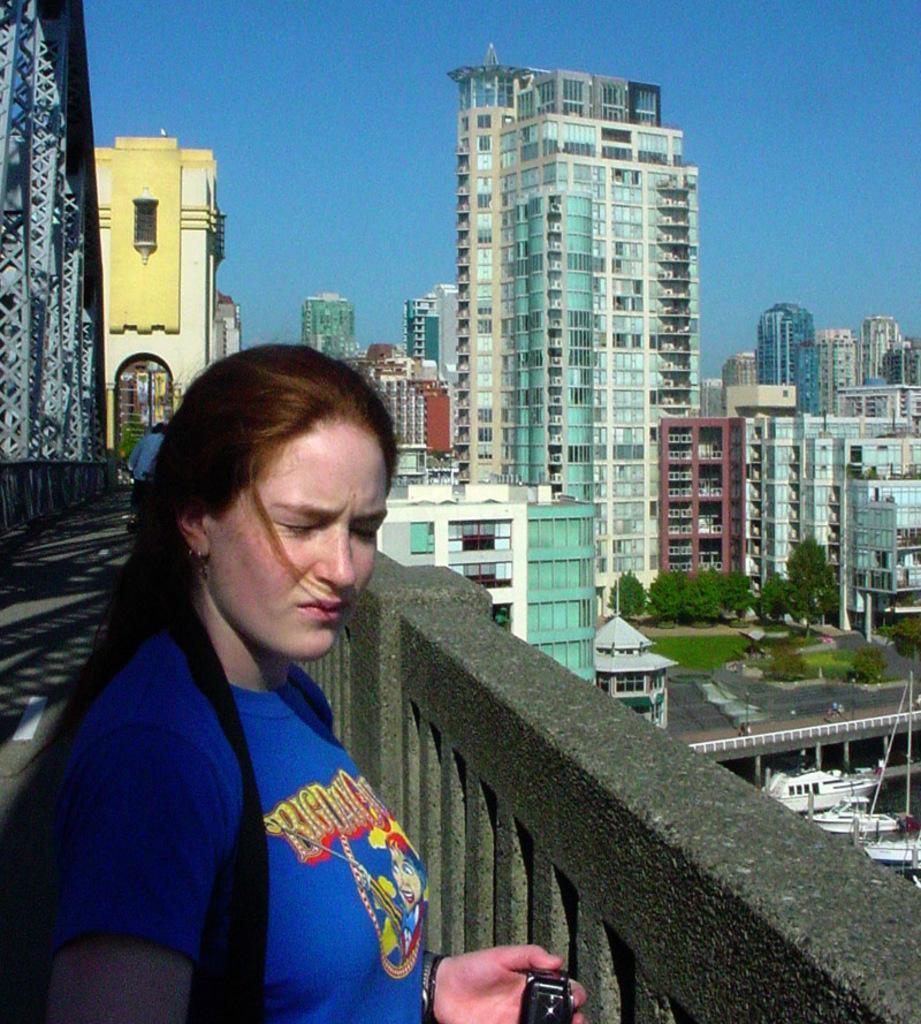In one or two sentences, can you explain what this image depicts? In this image, we can see some buildings. There is a person in the bottom left of the image wearing clothes. There is a bridge on the left side of the image. There are some boats in the bottom right of the image. There is a sky at the top of the image. 